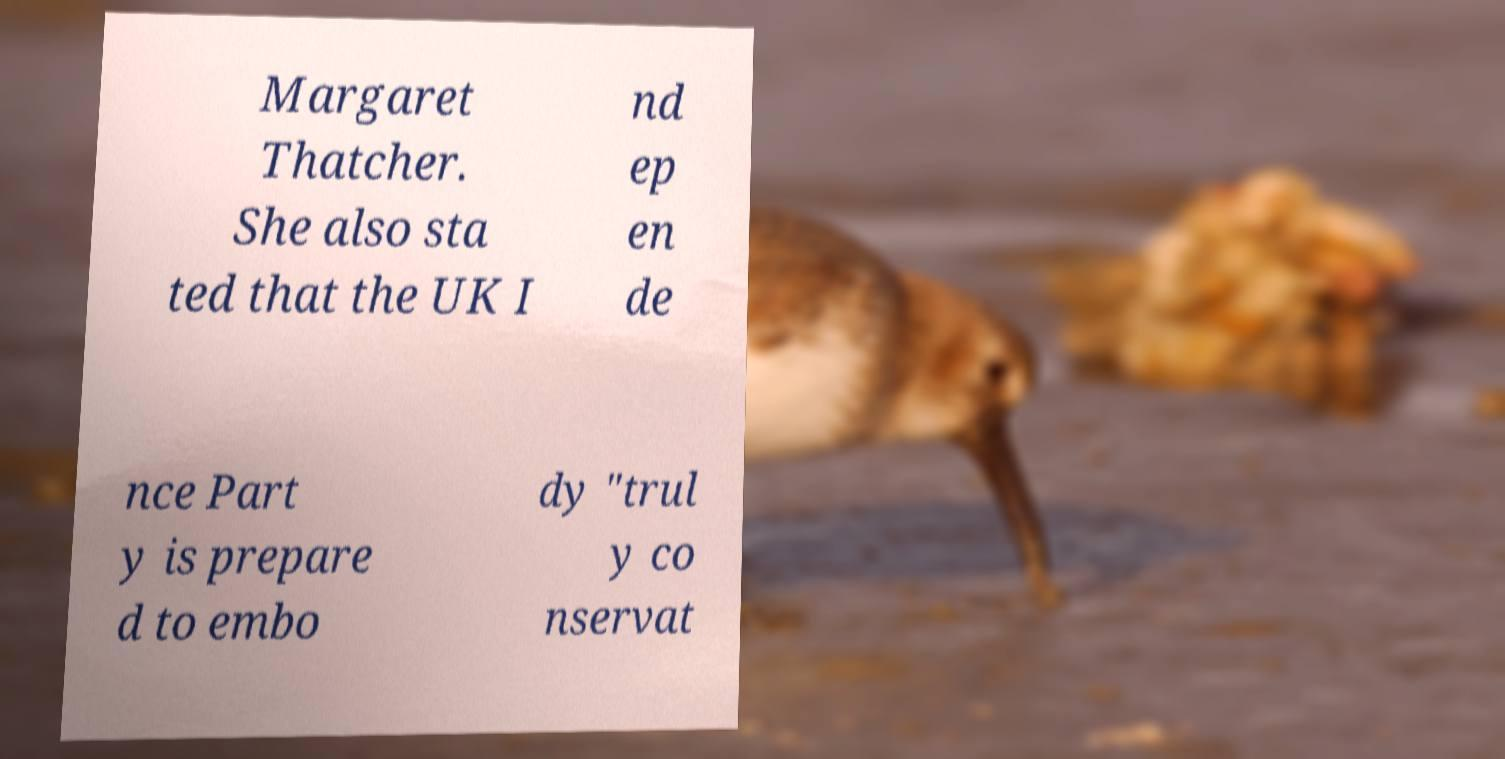Please read and relay the text visible in this image. What does it say? Margaret Thatcher. She also sta ted that the UK I nd ep en de nce Part y is prepare d to embo dy "trul y co nservat 